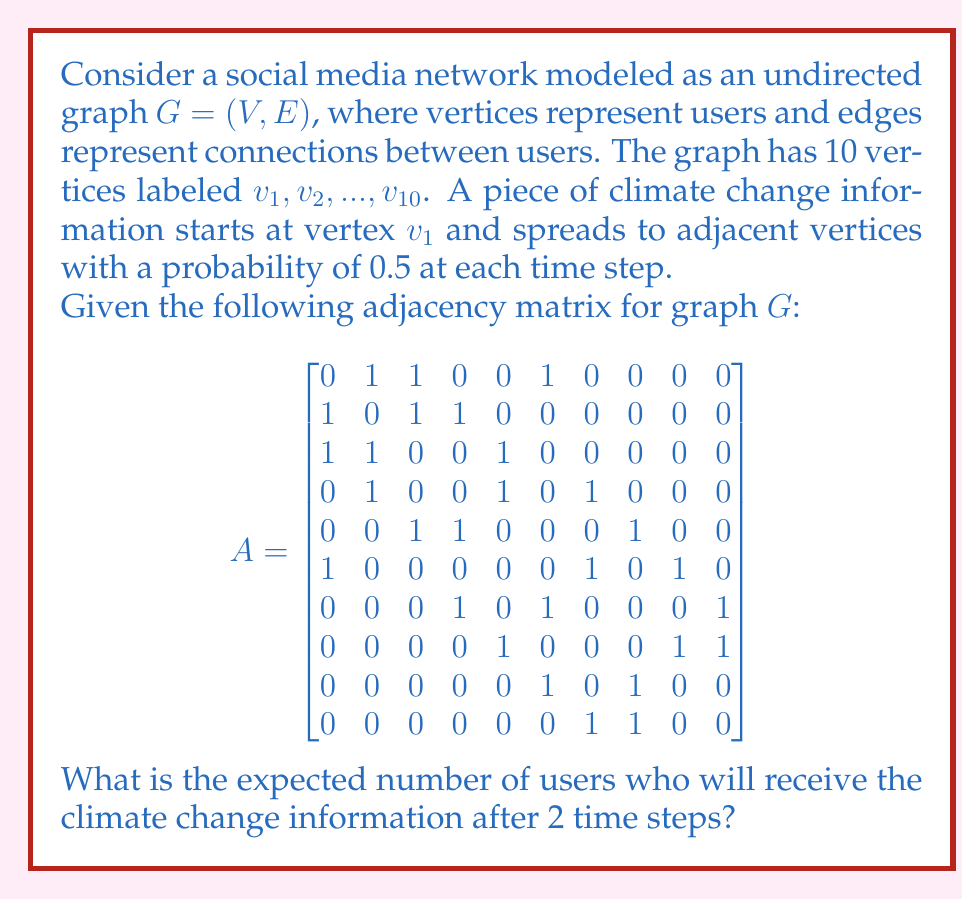Solve this math problem. To solve this problem, we'll follow these steps:

1) Identify the vertices that can be reached in 1 and 2 steps from $v_1$.
2) Calculate the probability of the information reaching each vertex.
3) Sum these probabilities to get the expected number of informed users.

Step 1: Identifying reachable vertices
- In 1 step: $v_2$, $v_3$, and $v_6$ (directly connected to $v_1$)
- In 2 steps: 
  - From $v_2$: $v_4$
  - From $v_3$: $v_5$
  - From $v_6$: $v_7$ and $v_9$

Step 2: Calculating probabilities
- $v_1$: 1 (starting point)
- $v_2$, $v_3$, $v_6$: 0.5 each (1 step)
- $v_4$, $v_5$: $0.5 \times 0.5 = 0.25$ each (2 steps via $v_2$ or $v_3$)
- $v_7$, $v_9$: $0.5 \times 0.5 = 0.25$ each (2 steps via $v_6$)

Step 3: Summing probabilities
Expected number = $1 + 0.5 + 0.5 + 0.5 + 0.25 + 0.25 + 0.25 + 0.25 = 3.5$

Therefore, after 2 time steps, the expected number of users who will receive the climate change information is 3.5.
Answer: 3.5 users 